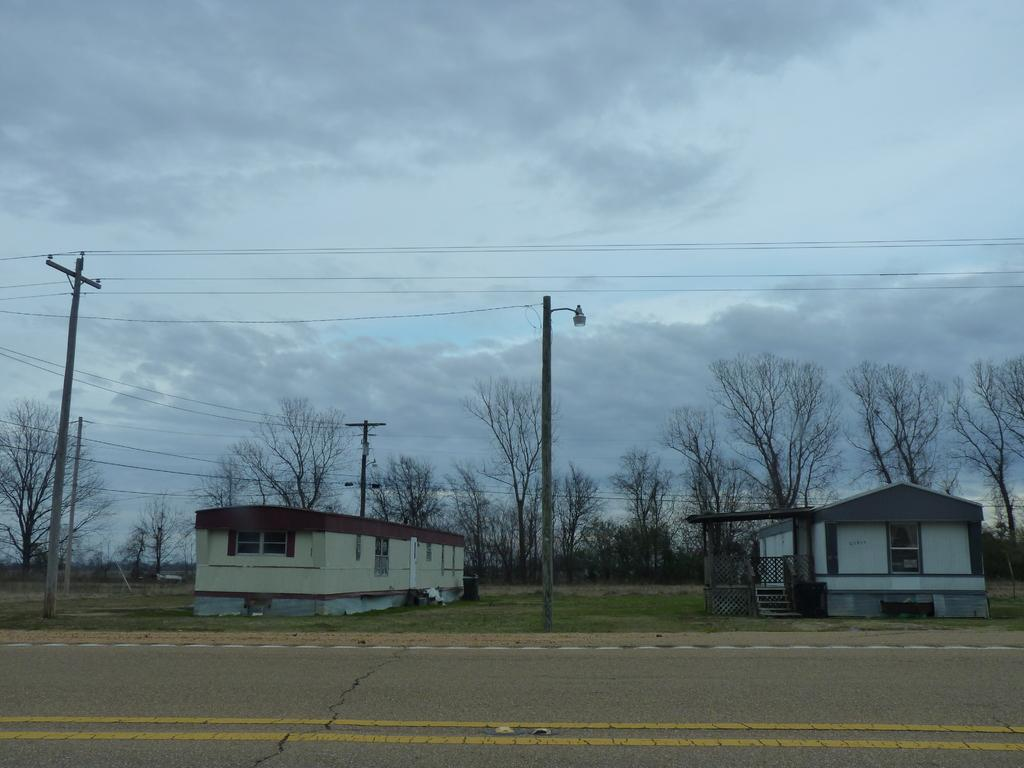What type of structures are in the foreground of the image? There are houses in the foreground of the image. What other objects can be seen in the foreground of the image? Street lights, wires, grass, and trees are visible in the foreground of the image. What is visible at the top of the image? The sky is visible at the top of the image. When was the image taken? The image was taken during the day. What type of curtain is hanging in the trees in the image? There is no curtain present in the trees in the image. What message of peace is conveyed by the image? The image does not convey a specific message of peace; it simply shows houses, street lights, wires, grass, trees, and the sky. 